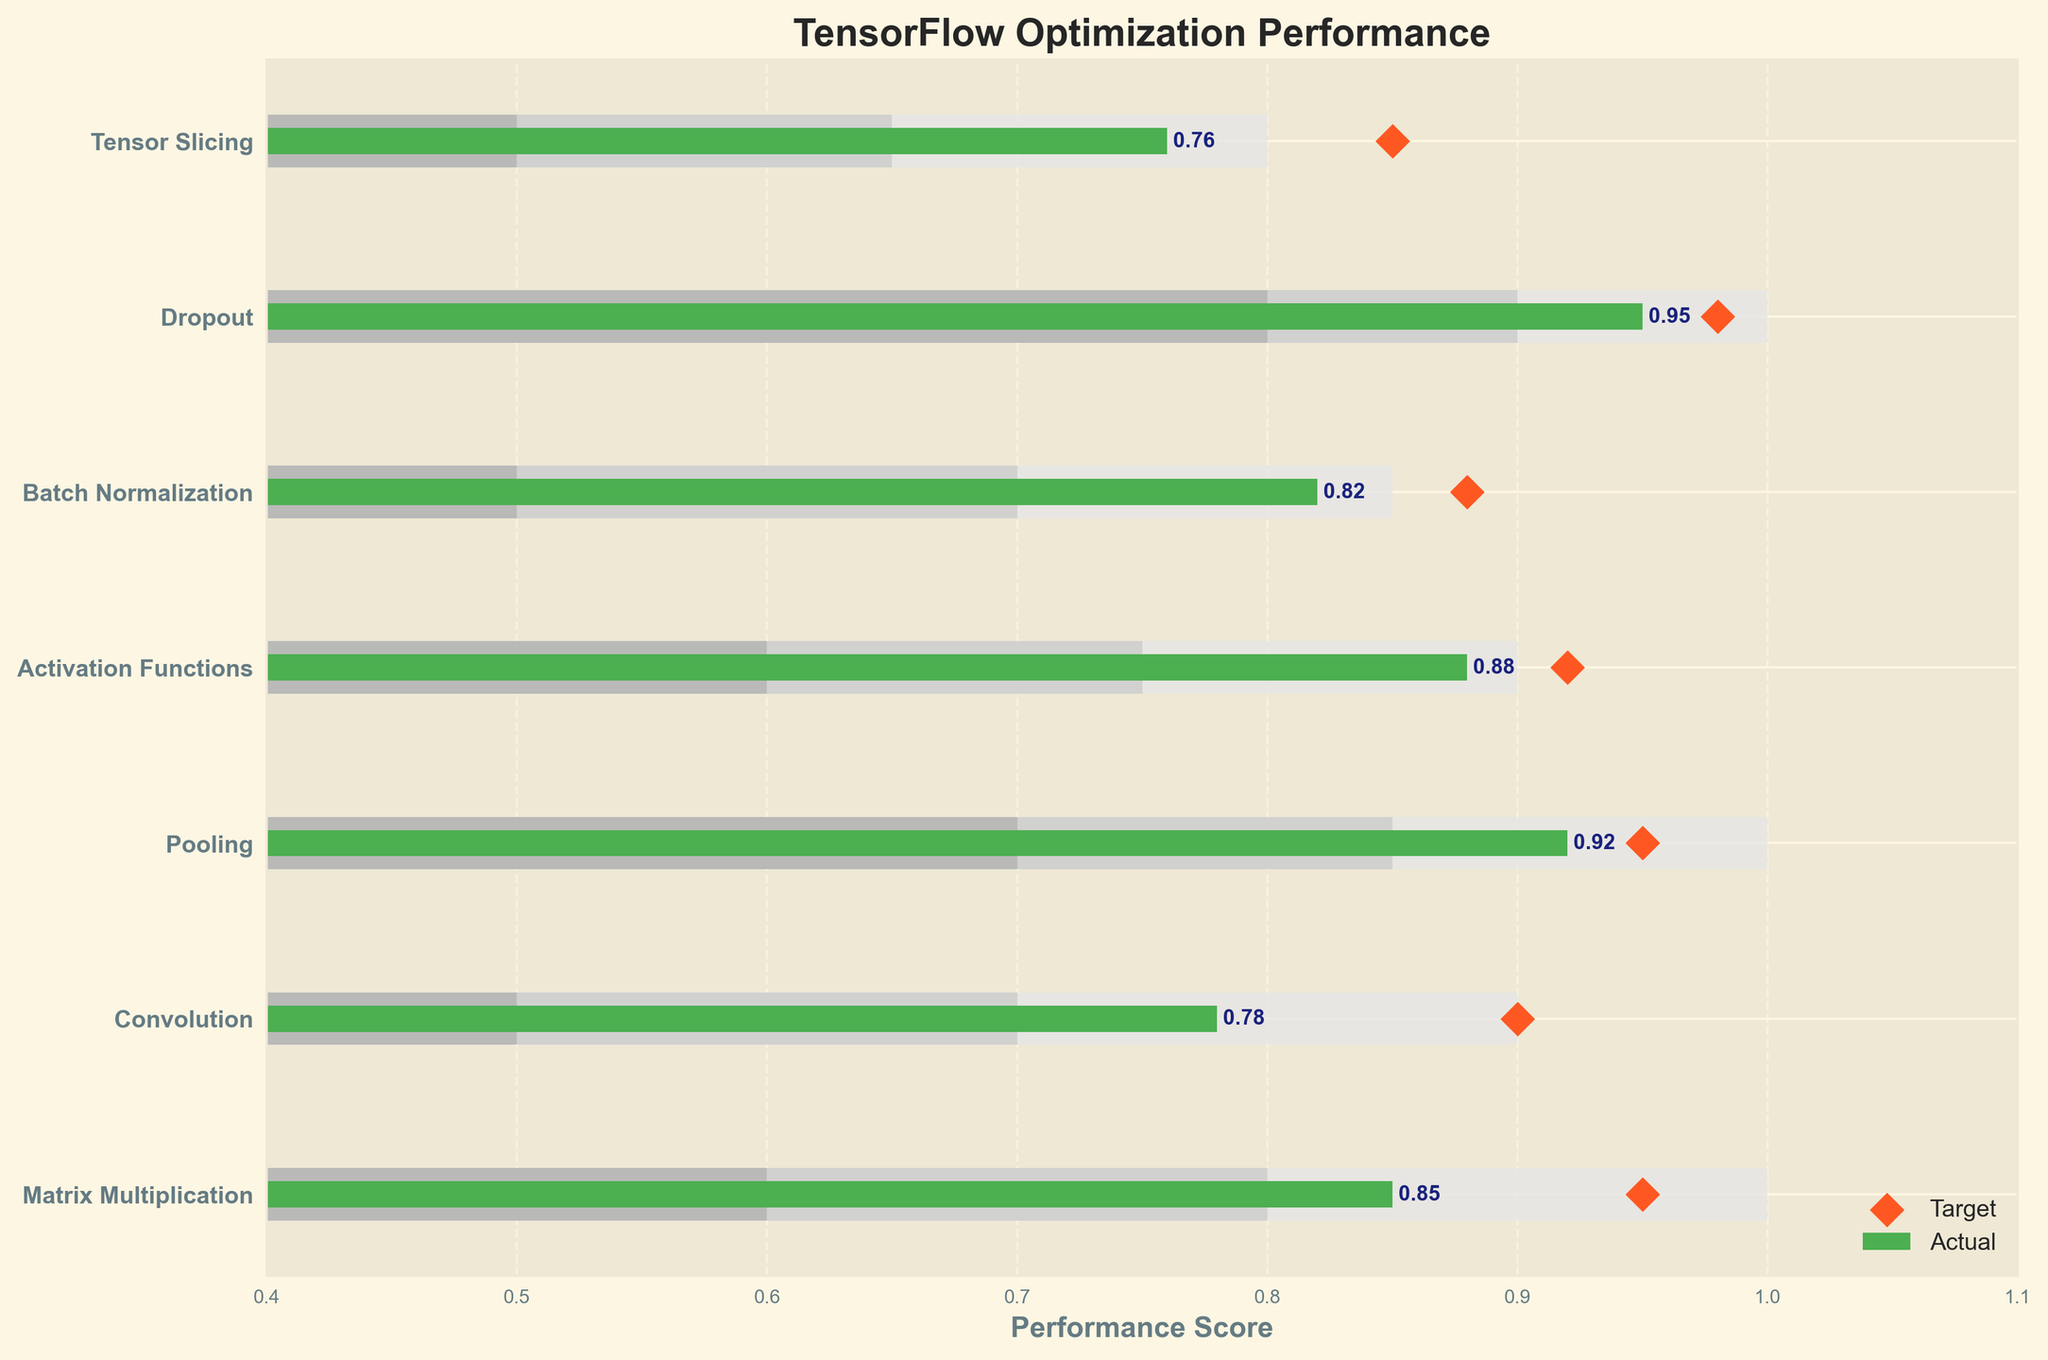What is the title of the plot? The title of the plot is shown at the top. It reads "TensorFlow Optimization Performance".
Answer: TensorFlow Optimization Performance Which category has the highest actual performance value? By looking at the actual performance values (green bars), Dropout has the highest actual performance value of 0.95.
Answer: Dropout How many categories have an actual performance value above 0.80? We observe six categories: Matrix Multiplication (0.85), Convolution (0.78), Pooling (0.92), Activation Functions (0.88), Batch Normalization (0.82), and Dropout (0.95), indicating all except Tensor Slicing (0.76) have actual values above 0.80.
Answer: 5 Is the actual performance value of Convolution above its target performance? The actual performance (green bar) of Convolution is 0.78, while the target (orange diamond) is 0.90, meaning it is below the target.
Answer: No Which category has the smallest gap between actual and target performances? The category with the smallest difference between actual and target is Activation Functions, with actual 0.88 and target 0.92, a difference of 0.04.
Answer: Activation Functions Which category's actual performance falls within its middle range? The actual performance of Convolution (0.78) falls within the middle range (0.7 - 0.9).
Answer: Convolution What's the average target performance across all categories? Summing the target performances (0.95 + 0.90 + 0.95 + 0.92 + 0.88 + 0.98 + 0.85) equals 6.43. Dividing by 7 (number of categories) gives an average of 0.9186 (rounded to four decimal places).
Answer: 0.9186 How many categories achieved their target performance? None of the categories with actual performance values (green bars) meet or exceed their target performance values (orange diamonds).
Answer: 0 Among Pooling and Batch Normalization, which has a higher actual performance value? Pooling's actual value is 0.92, while Batch Normalization's is 0.82, hence Pooling has a higher actual performance value.
Answer: Pooling In which range does the actual performance value of Matrix Multiplication fall? The actual performance of Matrix Multiplication is 0.85, which falls within its highest range (0.8 - 1.0).
Answer: Highest range 